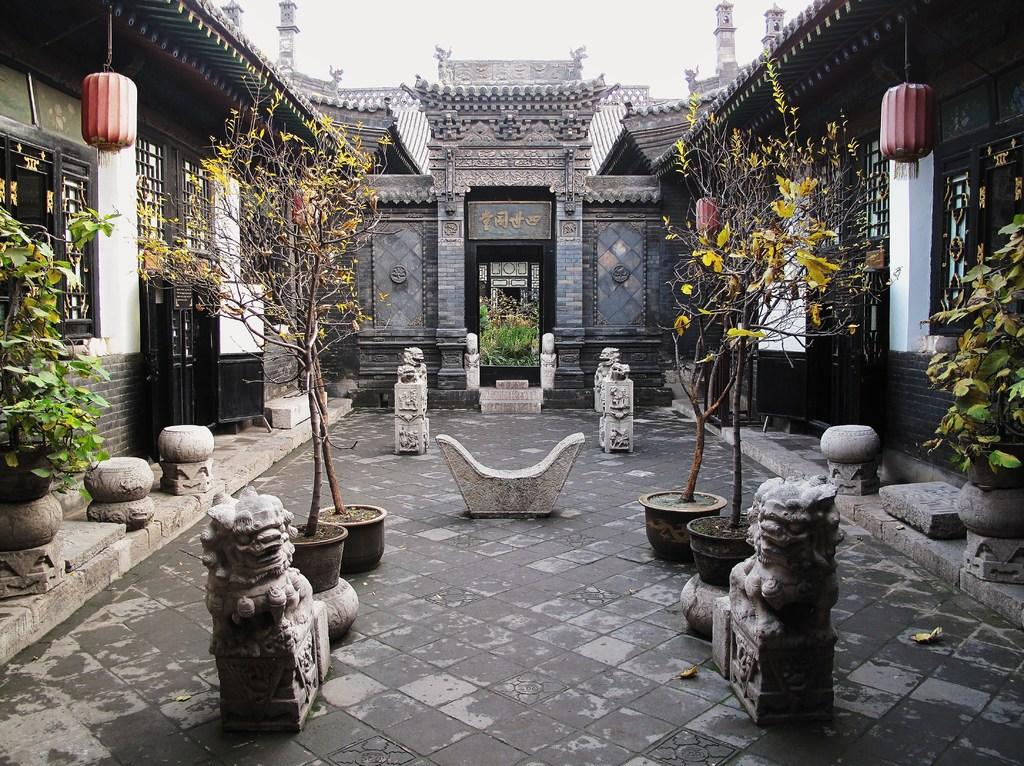What type of structure is present in the image? There is a building in the image. What architectural features can be seen on the building? The building has windows. Are there any decorative elements in the image? Yes, there are flowerpots and statues in the image. How can the building be accessed? There is a door in the image. What is the color of the sky in the image? The sky is white in color. What type of bells can be heard ringing in the image? There are no bells present in the image, and therefore no sound can be heard. What flavor of soda is being served in the image? There is no soda present in the image. 